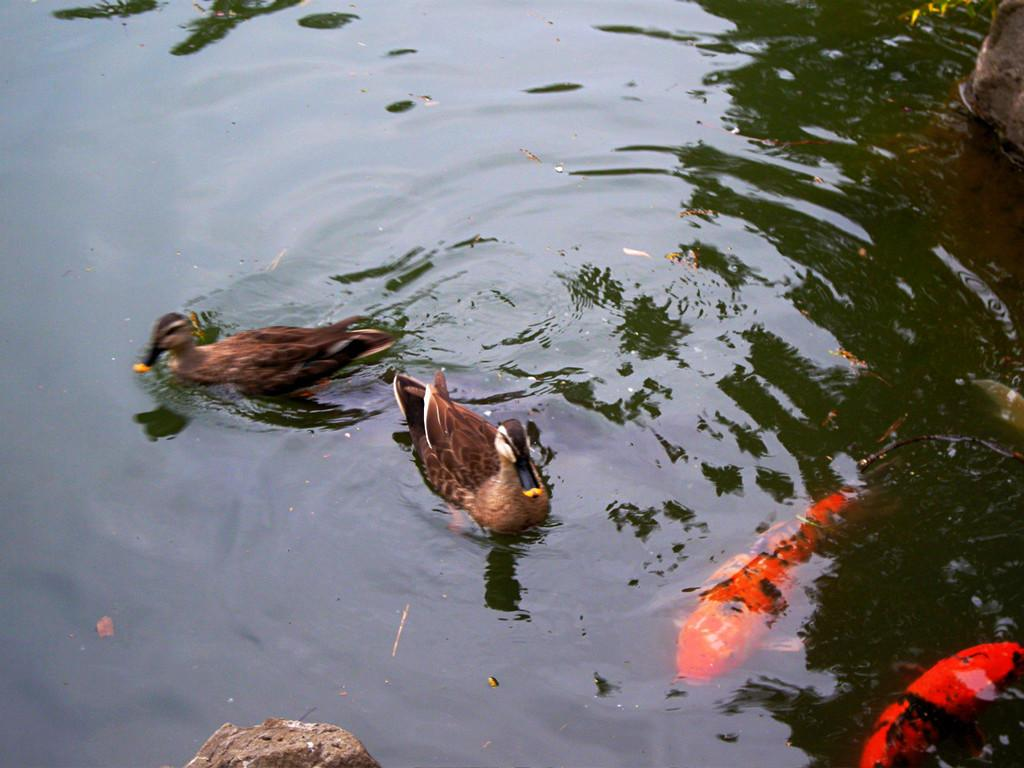What is the main feature of the image? There is a water body in the picture. What animals can be seen in the water? There are ducks in the middle of the picture and fishes visible inside the water on the right side. Can you describe any other objects in the image? There is a rock-like object at the bottom of the picture. What type of crime is being committed in the image? There is no indication of any crime being committed in the image; it features a water body with ducks, fishes, and a rock-like object. Is there a birthday celebration happening in the image? There is no indication of a birthday celebration in the image; it features a water body with ducks, fishes, and a rock-like object. 